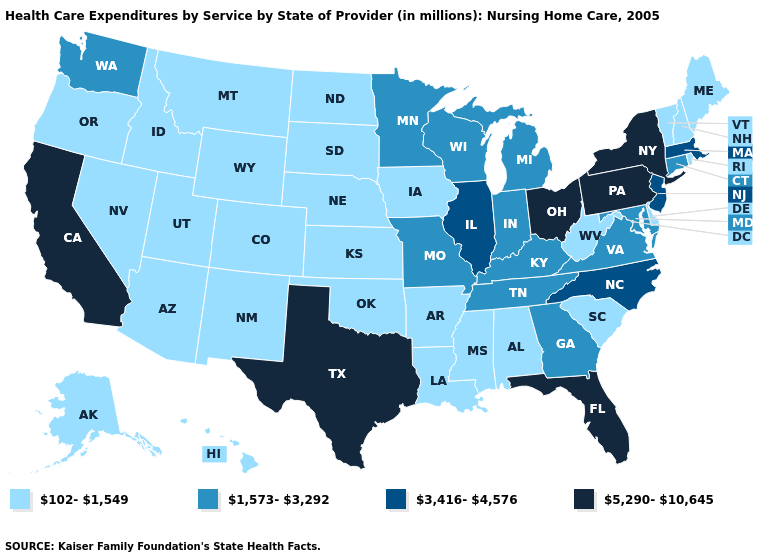Is the legend a continuous bar?
Write a very short answer. No. Does the map have missing data?
Concise answer only. No. Among the states that border Illinois , does Missouri have the highest value?
Write a very short answer. Yes. Among the states that border Idaho , which have the highest value?
Concise answer only. Washington. What is the value of Texas?
Give a very brief answer. 5,290-10,645. Which states have the lowest value in the South?
Concise answer only. Alabama, Arkansas, Delaware, Louisiana, Mississippi, Oklahoma, South Carolina, West Virginia. Does the first symbol in the legend represent the smallest category?
Concise answer only. Yes. What is the value of Alaska?
Give a very brief answer. 102-1,549. What is the value of Arizona?
Keep it brief. 102-1,549. What is the value of Kentucky?
Concise answer only. 1,573-3,292. Does New Hampshire have a higher value than Minnesota?
Answer briefly. No. What is the highest value in the USA?
Short answer required. 5,290-10,645. Which states have the highest value in the USA?
Concise answer only. California, Florida, New York, Ohio, Pennsylvania, Texas. What is the highest value in the Northeast ?
Give a very brief answer. 5,290-10,645. Name the states that have a value in the range 3,416-4,576?
Short answer required. Illinois, Massachusetts, New Jersey, North Carolina. 